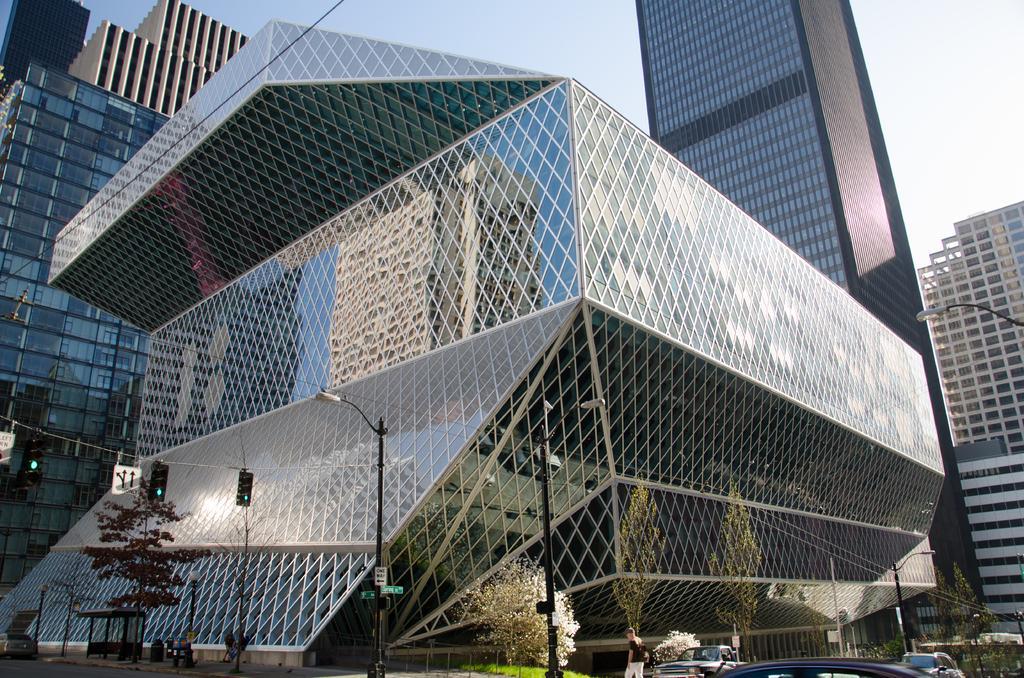Describe this image in one or two sentences. In the picture we can see a glass construction building and near to it, we can see some poles with street lights and some traffic lights and we can also see some cars and some person and behind the building we can see some tower buildings and a sky. 